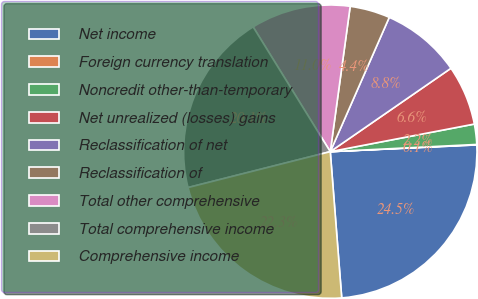Convert chart to OTSL. <chart><loc_0><loc_0><loc_500><loc_500><pie_chart><fcel>Net income<fcel>Foreign currency translation<fcel>Noncredit other-than-temporary<fcel>Net unrealized (losses) gains<fcel>Reclassification of net<fcel>Reclassification of<fcel>Total other comprehensive<fcel>Total comprehensive income<fcel>Comprehensive income<nl><fcel>24.49%<fcel>0.05%<fcel>2.23%<fcel>6.61%<fcel>8.79%<fcel>4.42%<fcel>10.98%<fcel>20.12%<fcel>22.31%<nl></chart> 